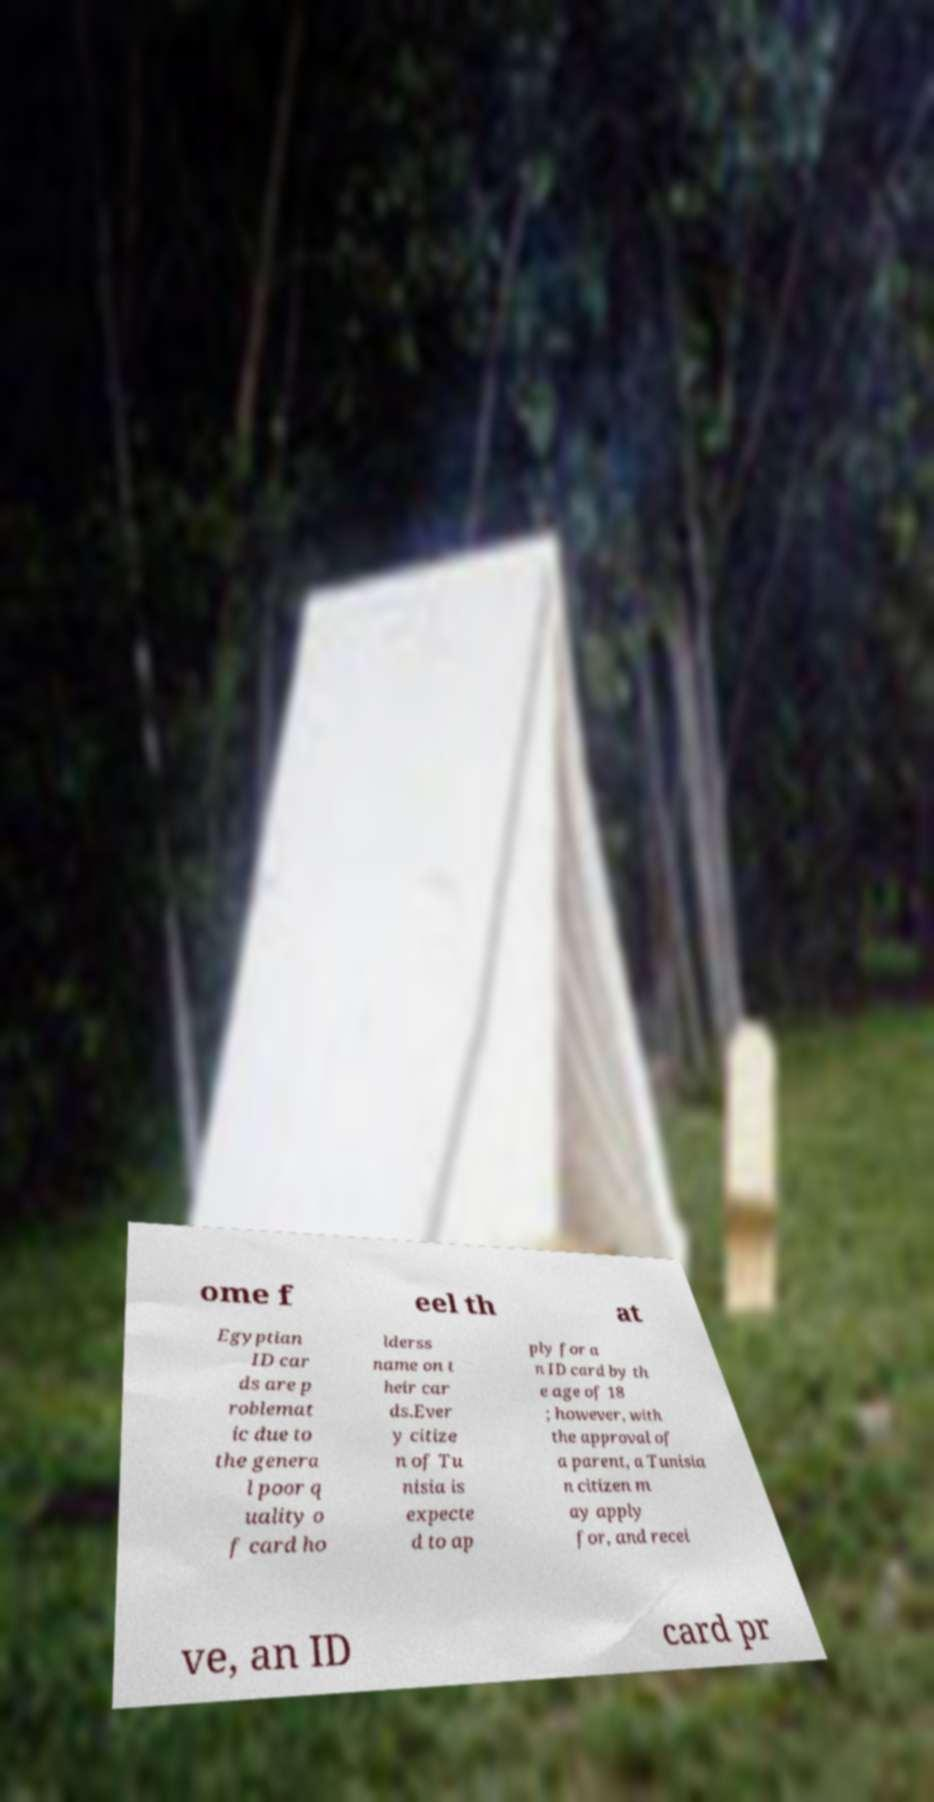Can you read and provide the text displayed in the image?This photo seems to have some interesting text. Can you extract and type it out for me? ome f eel th at Egyptian ID car ds are p roblemat ic due to the genera l poor q uality o f card ho lderss name on t heir car ds.Ever y citize n of Tu nisia is expecte d to ap ply for a n ID card by th e age of 18 ; however, with the approval of a parent, a Tunisia n citizen m ay apply for, and recei ve, an ID card pr 